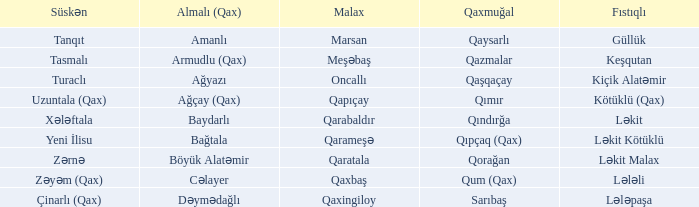What is the Süskən village with a Malax village meşəbaş? Tasmalı. I'm looking to parse the entire table for insights. Could you assist me with that? {'header': ['Süskən', 'Almalı (Qax)', 'Malax', 'Qaxmuğal', 'Fıstıqlı'], 'rows': [['Tanqıt', 'Amanlı', 'Marsan', 'Qaysarlı', 'Güllük'], ['Tasmalı', 'Armudlu (Qax)', 'Meşəbaş', 'Qazmalar', 'Keşqutan'], ['Turaclı', 'Ağyazı', 'Oncallı', 'Qaşqaçay', 'Kiçik Alatəmir'], ['Uzuntala (Qax)', 'Ağçay (Qax)', 'Qapıçay', 'Qımır', 'Kötüklü (Qax)'], ['Xələftala', 'Baydarlı', 'Qarabaldır', 'Qındırğa', 'Ləkit'], ['Yeni İlisu', 'Bağtala', 'Qarameşə', 'Qıpçaq (Qax)', 'Ləkit Kötüklü'], ['Zərnə', 'Böyük Alatəmir', 'Qaratala', 'Qorağan', 'Ləkit Malax'], ['Zəyəm (Qax)', 'Cəlayer', 'Qaxbaş', 'Qum (Qax)', 'Lələli'], ['Çinarlı (Qax)', 'Dəymədağlı', 'Qaxingiloy', 'Sarıbaş', 'Lələpaşa']]} 